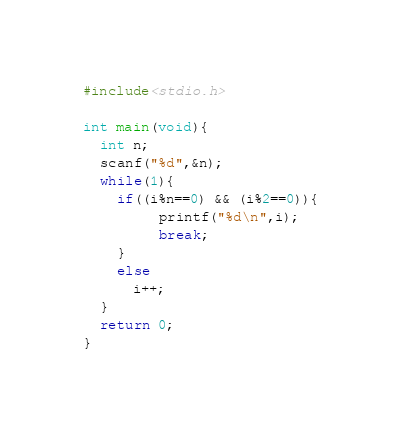<code> <loc_0><loc_0><loc_500><loc_500><_C_>#include<stdio.h>

int main(void){
  int n;
  scanf("%d",&n);
  while(1){
    if((i%n==0) && (i%2==0)){
         printf("%d\n",i);
         break;
    }
    else
      i++;
  }
  return 0;
}
</code> 